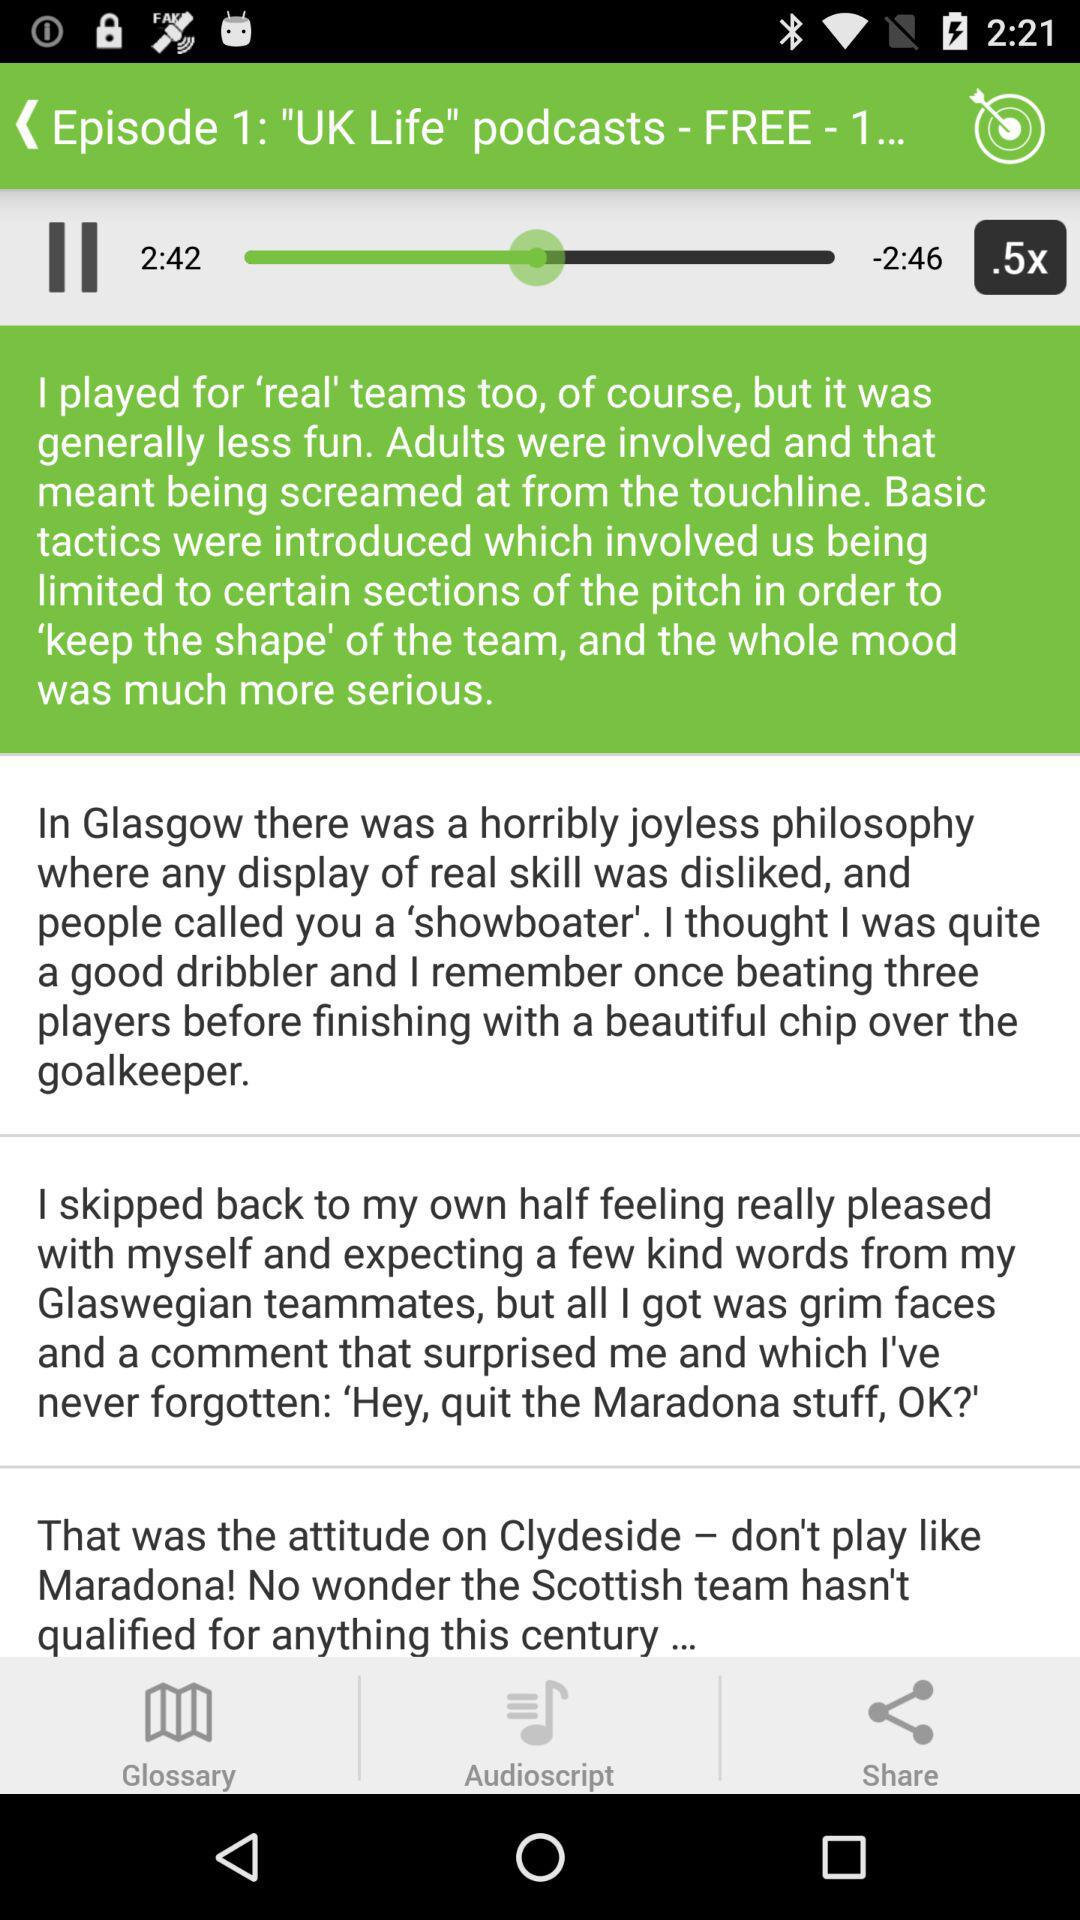Is "UK Life" an audio or video series? "UK Life" is an audio series. 